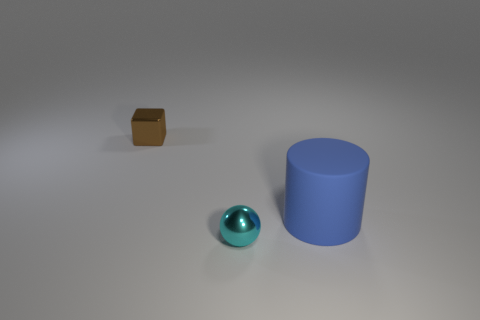Add 3 purple matte cylinders. How many objects exist? 6 Subtract all cubes. How many objects are left? 2 Add 3 small cyan metal objects. How many small cyan metal objects exist? 4 Subtract 1 brown blocks. How many objects are left? 2 Subtract all tiny objects. Subtract all blue things. How many objects are left? 0 Add 3 small shiny spheres. How many small shiny spheres are left? 4 